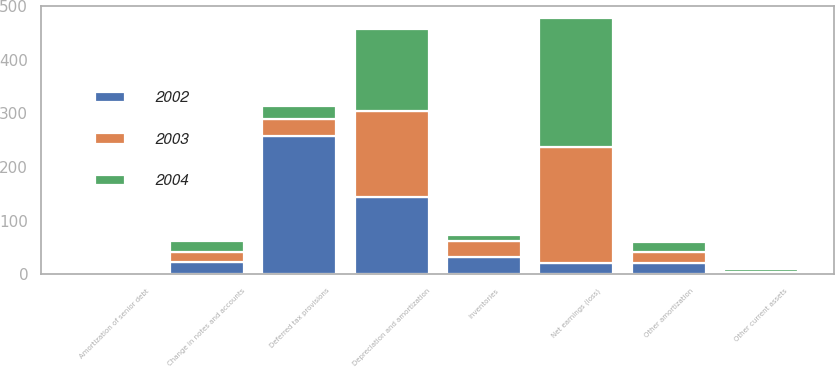<chart> <loc_0><loc_0><loc_500><loc_500><stacked_bar_chart><ecel><fcel>Net earnings (loss)<fcel>Depreciation and amortization<fcel>Other amortization<fcel>Amortization of senior debt<fcel>Deferred tax provisions<fcel>Change in notes and accounts<fcel>Inventories<fcel>Other current assets<nl><fcel>2003<fcel>215.6<fcel>159.6<fcel>19.9<fcel>3.2<fcel>32.7<fcel>19.1<fcel>29.1<fcel>2.4<nl><fcel>2004<fcel>240.4<fcel>154.1<fcel>19.1<fcel>2.4<fcel>23.4<fcel>20.3<fcel>11.6<fcel>5.4<nl><fcel>2002<fcel>20.9<fcel>144.1<fcel>20.9<fcel>1.3<fcel>257.2<fcel>22.7<fcel>32.6<fcel>2.1<nl></chart> 